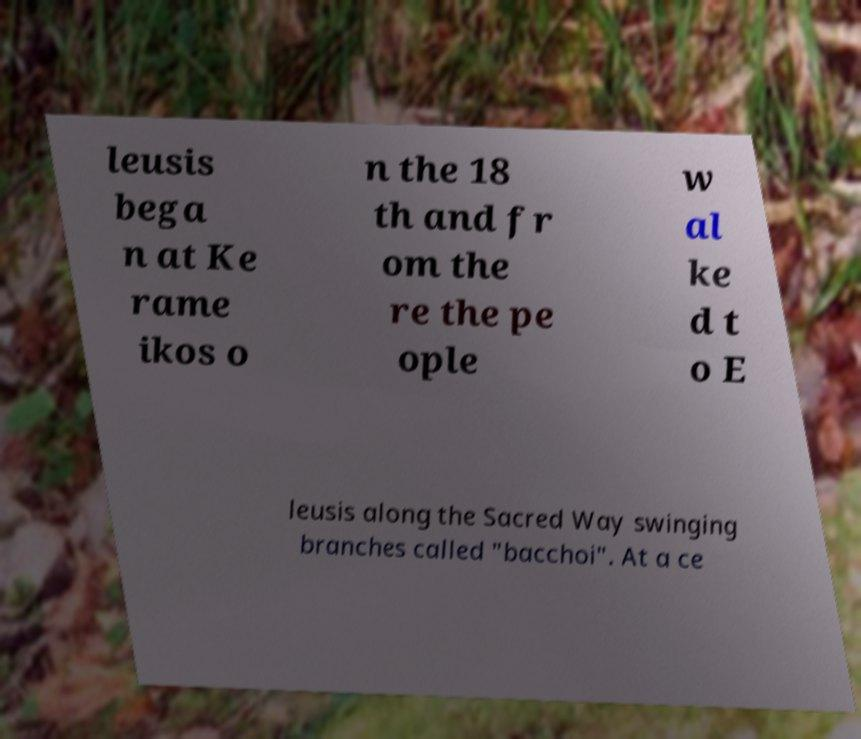For documentation purposes, I need the text within this image transcribed. Could you provide that? leusis bega n at Ke rame ikos o n the 18 th and fr om the re the pe ople w al ke d t o E leusis along the Sacred Way swinging branches called "bacchoi". At a ce 